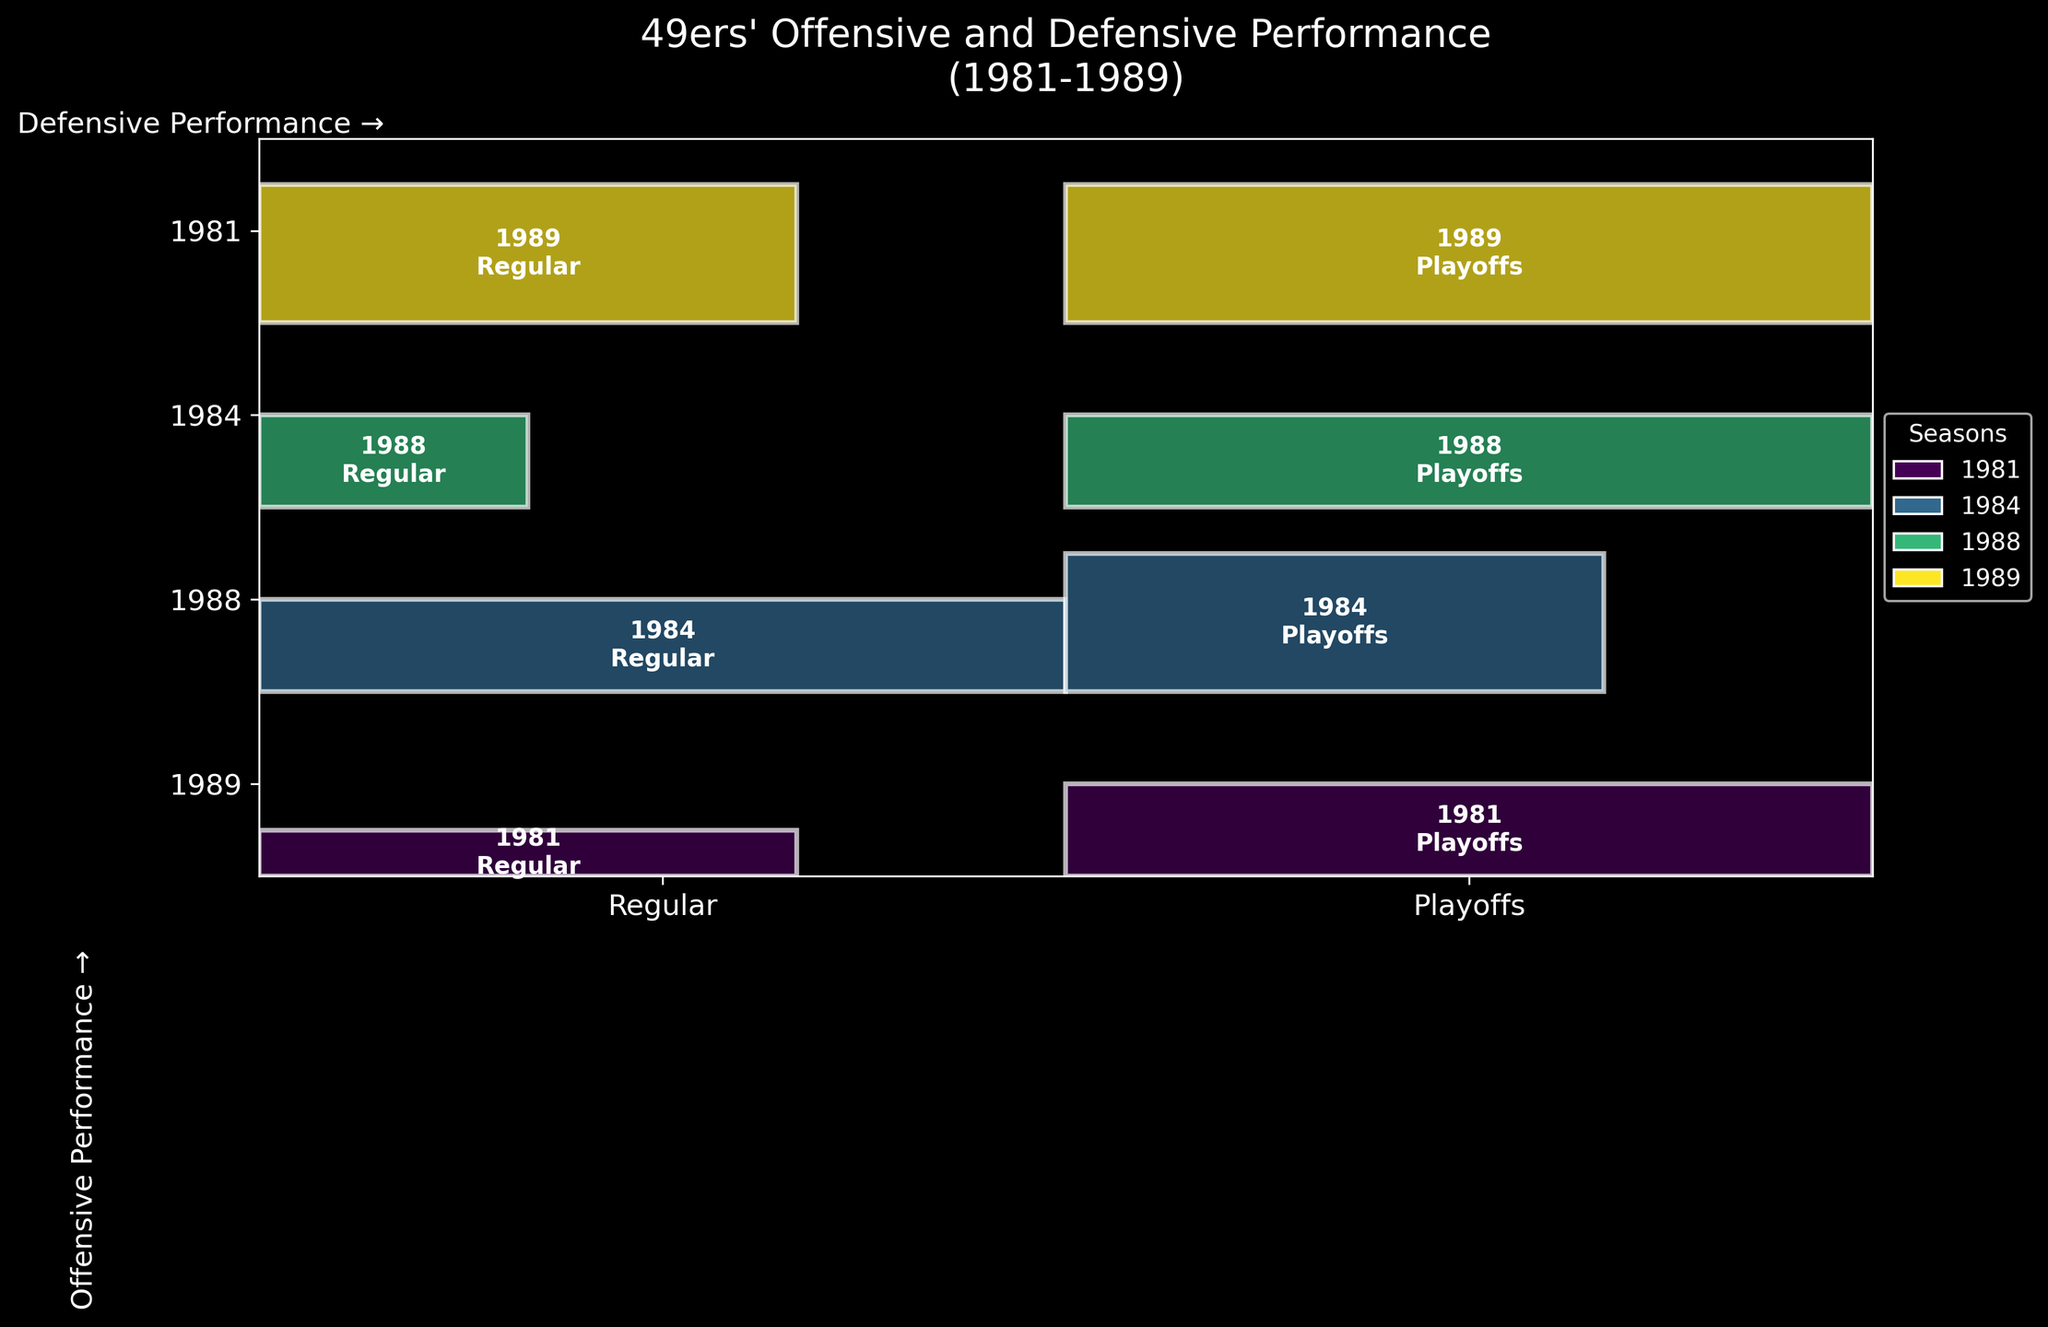How many unique seasons are depicted in the plot? The plot legends show different colors representing the seasons, and the y-tick labels indicate the years listed. Counting these, we find there are four unique seasons shown.
Answer: Four What does the plot title indicate about the time frame and focus of the performance data? The title, "49ers' Offensive and Defensive Performance (1981-1989)," indicates that the performance data spans from the years 1981 to 1989, focusing on both offensive and defensive performances.
Answer: 1981-1989, Offensive and Defensive Which season has the highest defensive performance during the playoffs? Looking at the height of the rectangles in the 'Playoffs' phase and referencing the y-tick labels, we see that the 1984 and 1989 seasons both have 'Very High' defensive performance in the playoffs.
Answer: 1984 and 1989 In which seasons was the offensive performance 'Very High' in the regular season? Checking the 'Regular' phase rectangles, we see that the 1984 and 1989 seasons have the rectangles extending to the 'Very High' offensive performance level.
Answer: 1984 and 1989 Compare the 1981 playoffs' performance to the 1981 regular season's performance. The 1981 playoffs' rectangle is taller and wider than the 1981 regular season's rectangle, indicating that both offensive and defensive performances were better during the playoffs.
Answer: Better in playoffs Which phase generally has higher offensive performance, regular season or playoffs? By comparing the width of rectangles in the 'Regular' and 'Playoffs' columns, we observe that the rectangles are generally wider in the 'Playoffs' phase.
Answer: Playoffs How does the defensive performance of the 1988 regular season compare to its playoffs? In the 1988 season, comparing the rectangles, the height for the regular season is equal to that of the playoffs, both are marked 'High'.
Answer: Same (High) What pattern can you observe regarding the 49ers' defensive performance in playoffs over the years? By looking at the height of rectangles in the 'Playoffs' column across different seasons, we see that defensive performance seems to consistently stay 'High' or 'Very High'.
Answer: Consistently High or Very High How many times has the 49ers' offensive performance reached 'Very High' in any phase in all visualized seasons? We count the frequency of the 'Very High' width in rectangles across all regular and playoff phases. It's present in 1981 Playoffs, 1984 Regular, 1988 Playoffs, and both phases in 1989.
Answer: Five 